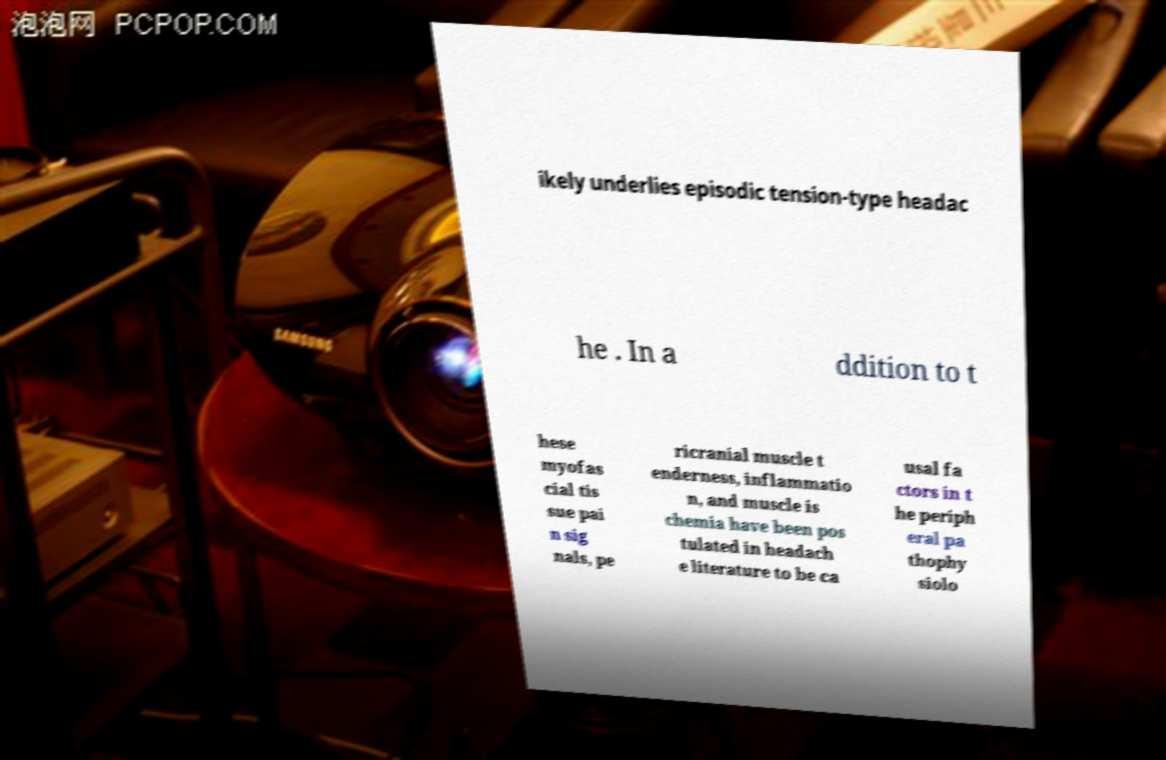Can you accurately transcribe the text from the provided image for me? ikely underlies episodic tension-type headac he . In a ddition to t hese myofas cial tis sue pai n sig nals, pe ricranial muscle t enderness, inflammatio n, and muscle is chemia have been pos tulated in headach e literature to be ca usal fa ctors in t he periph eral pa thophy siolo 